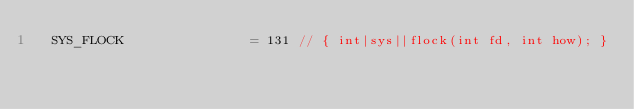Convert code to text. <code><loc_0><loc_0><loc_500><loc_500><_Go_>	SYS_FLOCK                = 131 // { int|sys||flock(int fd, int how); }</code> 